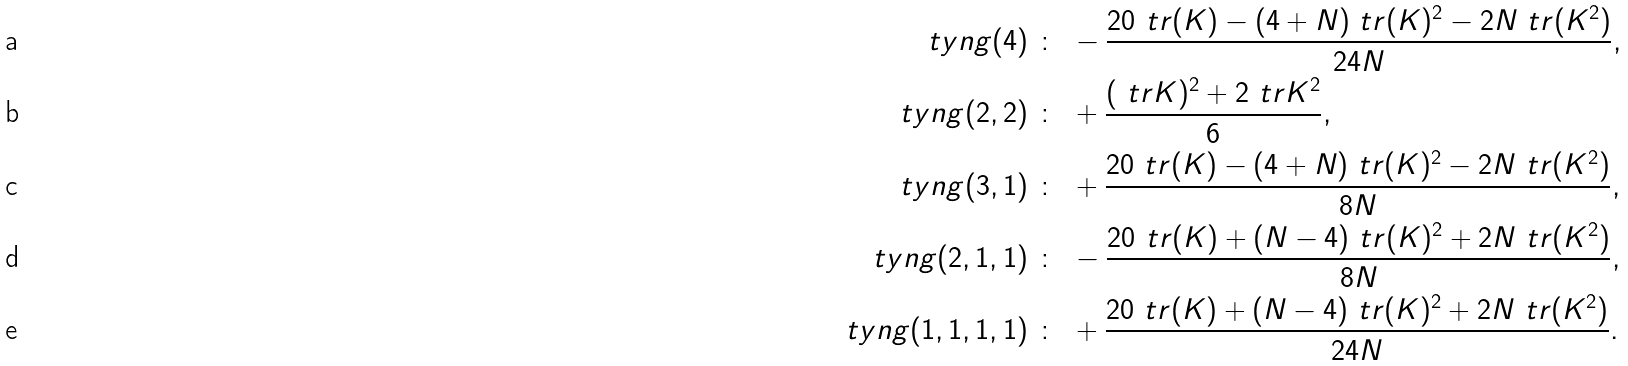Convert formula to latex. <formula><loc_0><loc_0><loc_500><loc_500>\ t y n g ( 4 ) & \ \colon \ - \frac { 2 0 \ t r ( K ) - ( 4 + N ) \ t r ( K ) ^ { 2 } - 2 N \ t r ( K ^ { 2 } ) } { 2 4 N } , \\ \ t y n g ( 2 , 2 ) & \ \colon \ + \frac { ( \ t r K ) ^ { 2 } + 2 \ t r K ^ { 2 } } { 6 } , \\ \ t y n g ( 3 , 1 ) & \ \colon \ + \frac { 2 0 \ t r ( K ) - ( 4 + N ) \ t r ( K ) ^ { 2 } - 2 N \ t r ( K ^ { 2 } ) } { 8 N } , \\ \ t y n g ( 2 , 1 , 1 ) & \ \colon \ - \frac { 2 0 \ t r ( K ) + ( N - 4 ) \ t r ( K ) ^ { 2 } + 2 N \ t r ( K ^ { 2 } ) } { 8 N } , \\ \ t y n g ( 1 , 1 , 1 , 1 ) & \ \colon \ + \frac { 2 0 \ t r ( K ) + ( N - 4 ) \ t r ( K ) ^ { 2 } + 2 N \ t r ( K ^ { 2 } ) } { 2 4 N } .</formula> 